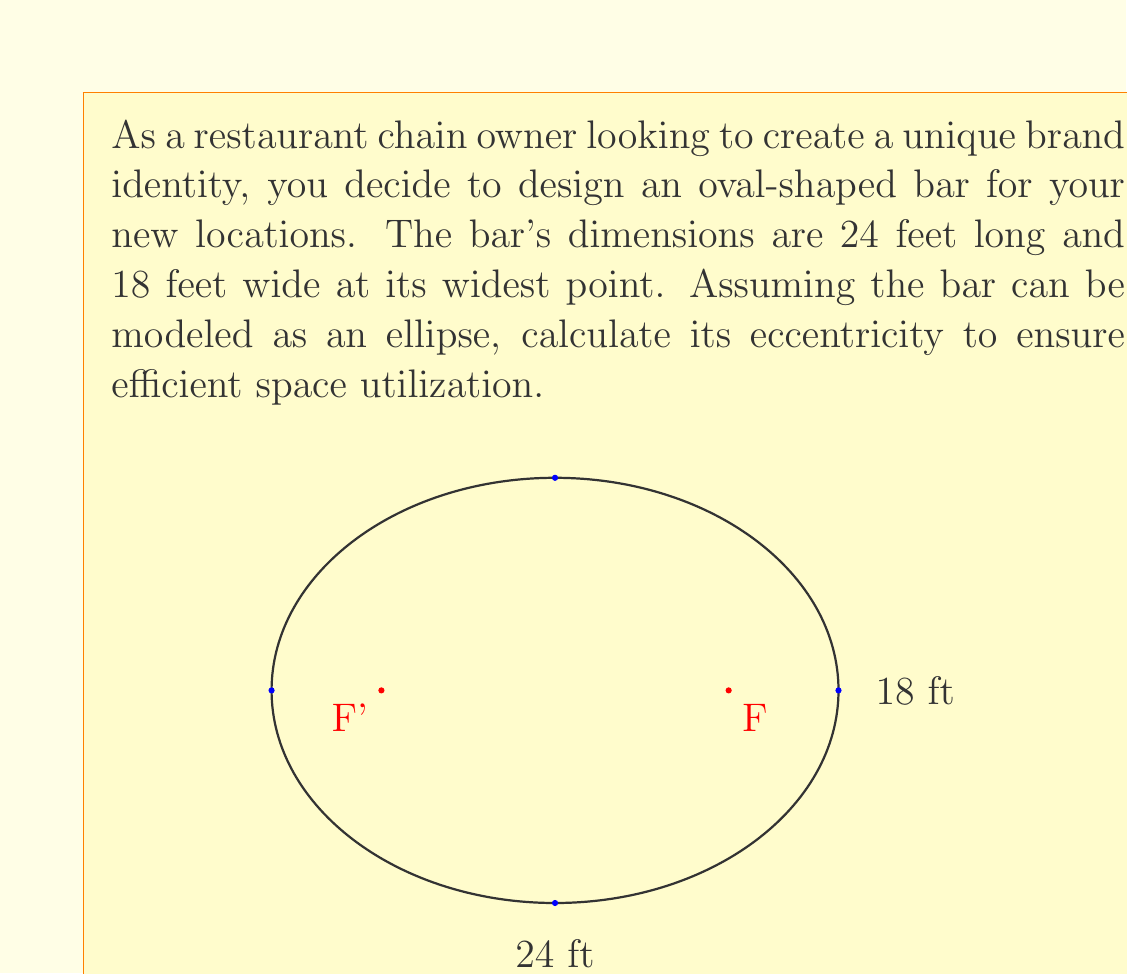Can you answer this question? To calculate the eccentricity of an ellipse, we need to follow these steps:

1) The eccentricity (e) of an ellipse is given by the formula:

   $$e = \frac{c}{a}$$

   where $c$ is the distance from the center to a focus, and $a$ is the length of the semi-major axis.

2) We're given the full length (24 feet) and width (18 feet) of the ellipse. Let's determine $a$ and $b$:
   
   $a = 24/2 = 12$ feet (semi-major axis)
   $b = 18/2 = 9$ feet (semi-minor axis)

3) To find $c$, we use the Pythagorean theorem for ellipses:

   $$a^2 = b^2 + c^2$$

4) Rearranging to solve for $c$:

   $$c^2 = a^2 - b^2$$
   $$c^2 = 12^2 - 9^2 = 144 - 81 = 63$$
   $$c = \sqrt{63} \approx 7.937$$

5) Now we can calculate the eccentricity:

   $$e = \frac{c}{a} = \frac{7.937}{12} \approx 0.6614$$

The eccentricity of the oval-shaped bar is approximately 0.6614.
Answer: $e \approx 0.6614$ 